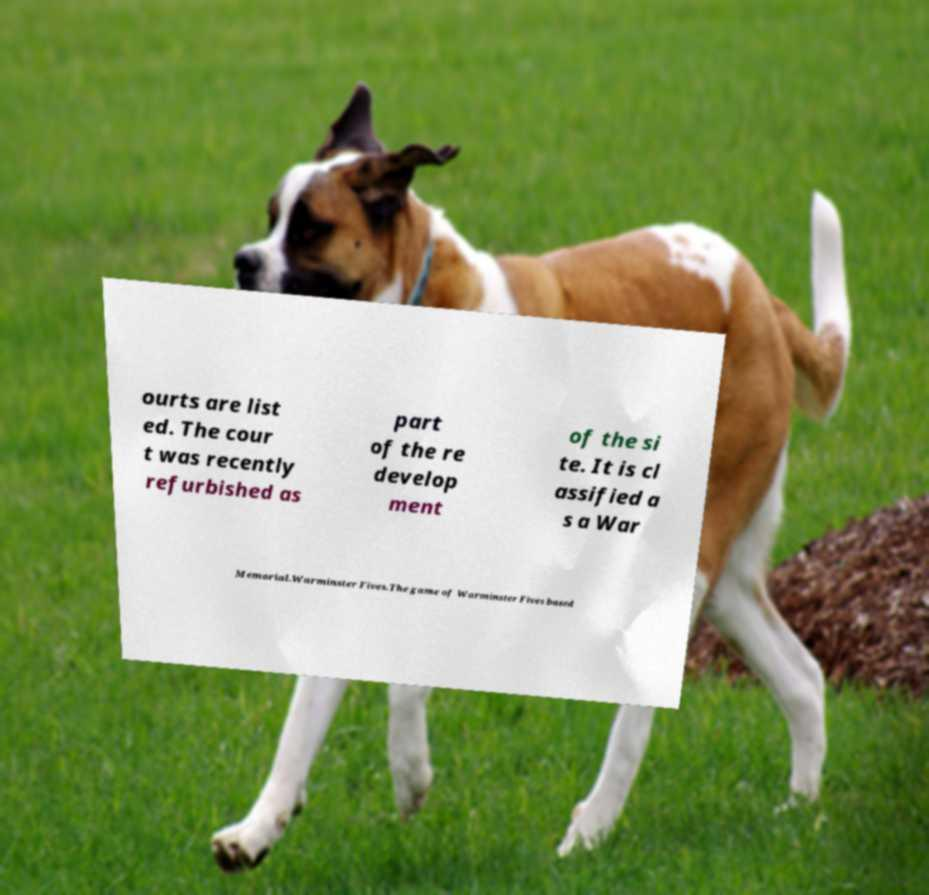For documentation purposes, I need the text within this image transcribed. Could you provide that? ourts are list ed. The cour t was recently refurbished as part of the re develop ment of the si te. It is cl assified a s a War Memorial.Warminster Fives.The game of Warminster Fives based 